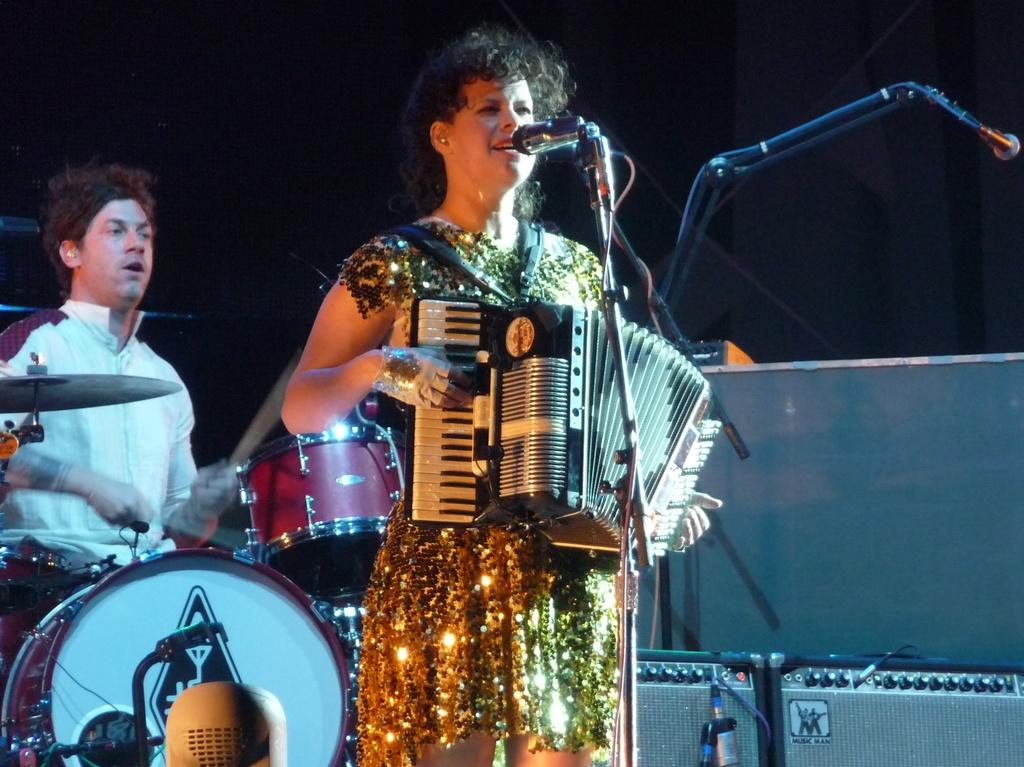What is the woman in the image doing? The woman is playing a musical instrument. What is the woman wearing in the image? The woman is wearing a golden color dress. What is the man in the image doing? The man is beating the drums. What is the man wearing in the image? The man is wearing a white color shirt. What is the title of the riddle that the woman is holding in the image? There is no riddle or title present in the image; the woman is playing a musical instrument. Can you see the man's tongue in the image? There is no indication of the man's tongue in the image. 